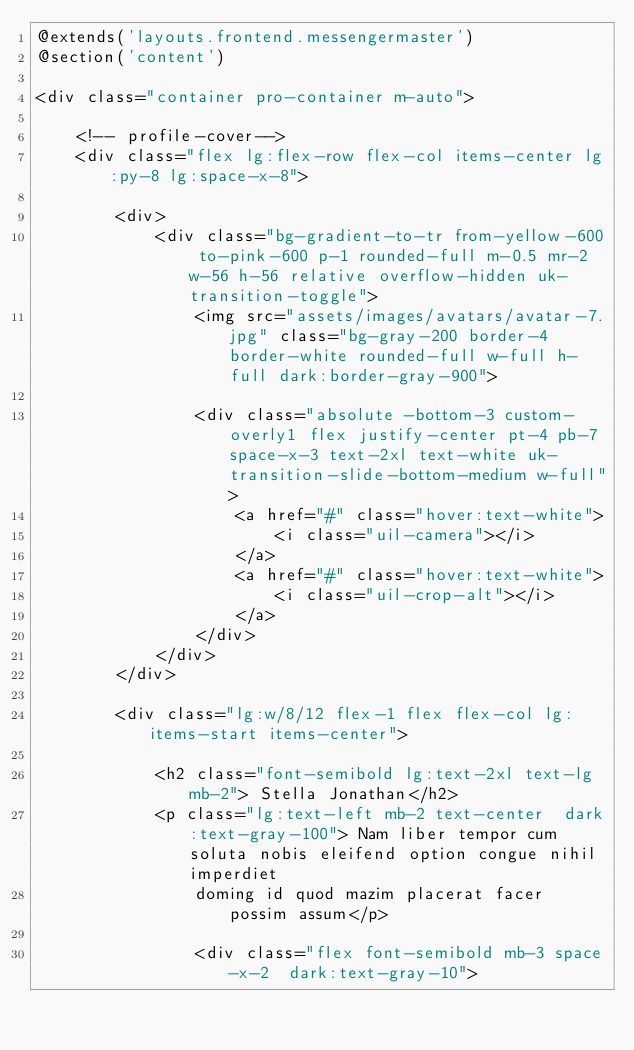Convert code to text. <code><loc_0><loc_0><loc_500><loc_500><_PHP_>@extends('layouts.frontend.messengermaster')
@section('content')

<div class="container pro-container m-auto">

    <!-- profile-cover-->
    <div class="flex lg:flex-row flex-col items-center lg:py-8 lg:space-x-8">

        <div>
            <div class="bg-gradient-to-tr from-yellow-600 to-pink-600 p-1 rounded-full m-0.5 mr-2  w-56 h-56 relative overflow-hidden uk-transition-toggle">
                <img src="assets/images/avatars/avatar-7.jpg" class="bg-gray-200 border-4 border-white rounded-full w-full h-full dark:border-gray-900">

                <div class="absolute -bottom-3 custom-overly1 flex justify-center pt-4 pb-7 space-x-3 text-2xl text-white uk-transition-slide-bottom-medium w-full">
                    <a href="#" class="hover:text-white">
                        <i class="uil-camera"></i>
                    </a>
                    <a href="#" class="hover:text-white">
                        <i class="uil-crop-alt"></i>
                    </a>
                </div>
            </div>
        </div>

        <div class="lg:w/8/12 flex-1 flex flex-col lg:items-start items-center">

            <h2 class="font-semibold lg:text-2xl text-lg mb-2"> Stella Jonathan</h2>
            <p class="lg:text-left mb-2 text-center  dark:text-gray-100"> Nam liber tempor cum soluta nobis eleifend option congue nihil imperdiet
                doming id quod mazim placerat facer possim assum</p>

                <div class="flex font-semibold mb-3 space-x-2  dark:text-gray-10"></code> 